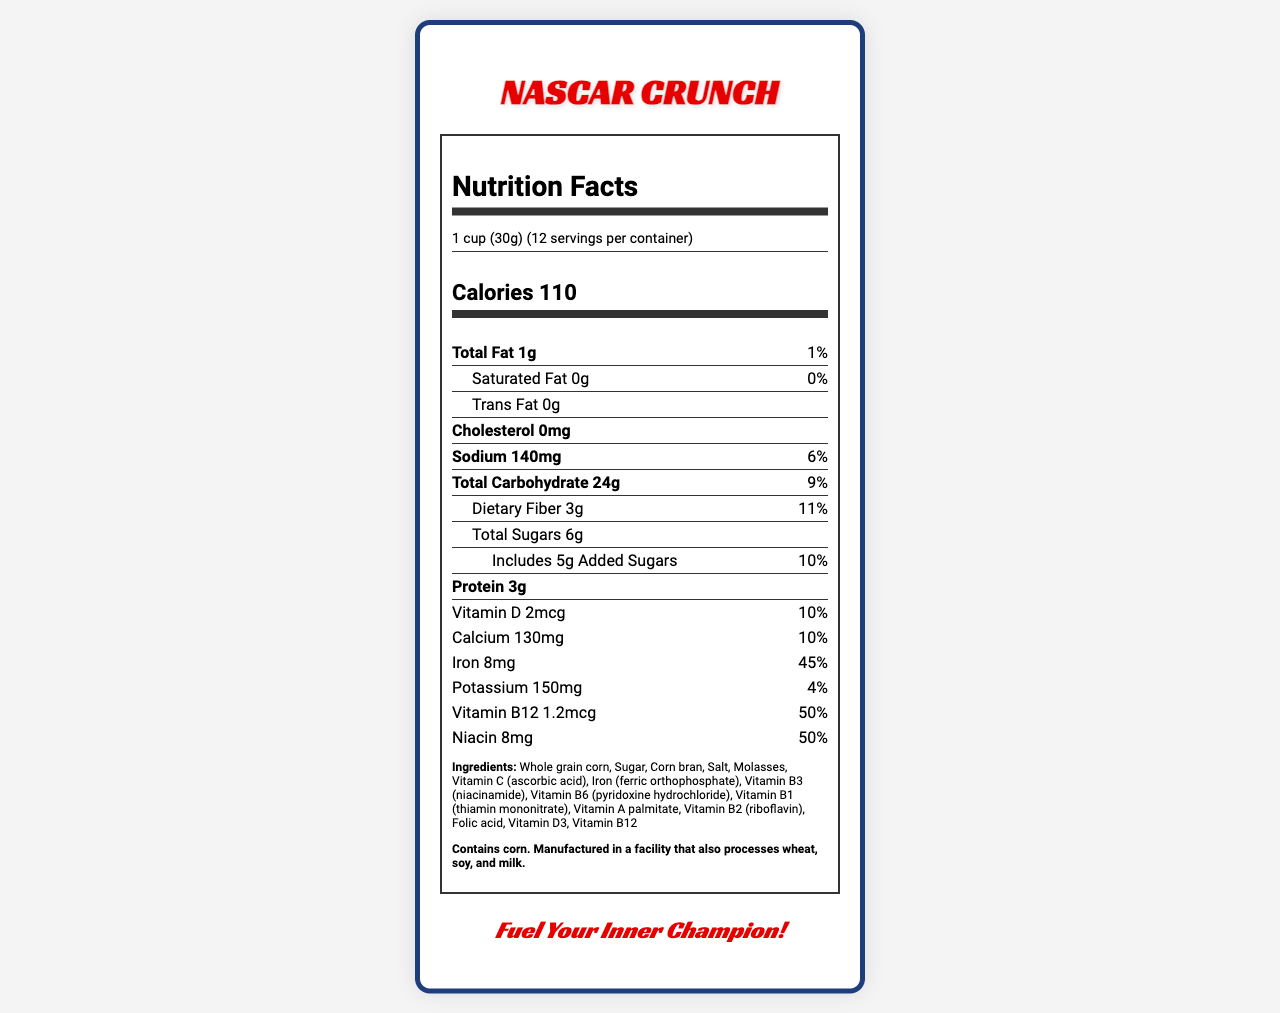what is the serving size? The serving size is specified as 1 cup (30g) in the document.
Answer: 1 cup (30g) how many servings are in the container? The document states there are 12 servings per container.
Answer: 12 what are the total calories per serving? The number of calories per serving is mentioned as 110.
Answer: 110 how much protein is in each serving? The amount of protein per serving is listed as 3g in the nutrient information.
Answer: 3g what percentage of the daily value of iron can one get from a serving? The daily value percentage for iron is provided as 45%.
Answer: 45% what is the product name? The product name given at the top of the document is NASCAR Crunch.
Answer: NASCAR Crunch who manufactures NASCAR Crunch? The manufacturer is mentioned as Rockingham Racing Foods, Inc.
Answer: Rockingham Racing Foods, Inc. how much dietary fiber is in each serving? A. 1g B. 3g C. 5g D. 7g The nutrient information lists 3g of dietary fiber per serving.
Answer: B what is the total fat content per serving? A. 2g B. 4g C. 1g The document indicates that the total fat content per serving is 1g.
Answer: C is there any cholesterol in NASCAR Crunch? A. Yes B. No The cholesterol content is specified as 0mg, indicating there is no cholesterol.
Answer: B is this product suitable for someone allergic to soy? The allergen information states it is manufactured in a facility that also processes soy.
Answer: No summarize the main idea of this document. The main elements include the product name, serving size, calories, nutrients list with daily value percentages, ingredients, allergen info, marketing tagline, special features, and manufacturer details.
Answer: The document provides detailed nutritional information for NASCAR Crunch, a vitamin-fortified breakfast cereal marketed towards racing enthusiasts. It includes information on serving size, nutrient content, ingredients, allergen warnings, and special features promoting the product. how many grams of added sugars are in each serving? The added sugars amount per serving is given as 5g.
Answer: 5g what are the shapes of the cereal pieces? The product description mentions that the cereal is shaped like miniature stock cars.
Answer: Shaped like miniature stock cars what is the QR code on the box used for? The special features mention a QR code on the box for exclusive behind-the-scenes racing content.
Answer: The QR code links to exclusive behind-the-scenes racing content. does NASCAR Crunch contain any artificial colors? The document does not provide any information on whether there are artificial colors in NASCAR Crunch.
Answer: Not enough information 